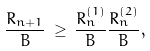<formula> <loc_0><loc_0><loc_500><loc_500>\frac { R _ { n + 1 } } { B } \, \geq \, \frac { R _ { n } ^ { ( 1 ) } } { B } \frac { R _ { n } ^ { ( 2 ) } } { B } ,</formula> 